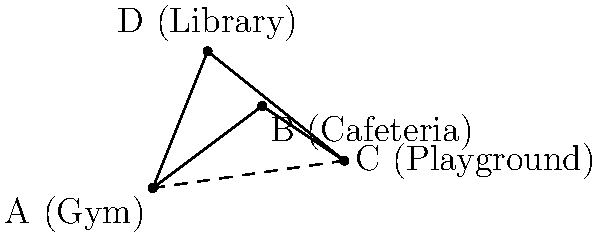As the school wellness coordinator, you're planning an efficient walking route between school facilities to encourage physical activity. Given the layout of the school facilities represented by vectors, where A is the gym, B is the cafeteria, C is the playground, and D is the library, what is the magnitude of the vector from the gym (A) to the playground (C)? To find the magnitude of the vector from the gym (A) to the playground (C), we need to follow these steps:

1. Identify the coordinates of points A and C:
   A (Gym): (0, 0)
   C (Playground): (7, 1)

2. Calculate the vector $\vec{AC}$ by subtracting the coordinates of A from C:
   $\vec{AC} = (7-0, 1-0) = (7, 1)$

3. Use the magnitude formula for a 2D vector:
   For a vector $\vec{v} = (x, y)$, the magnitude is given by $|\vec{v}| = \sqrt{x^2 + y^2}$

4. Apply the formula to $\vec{AC}$:
   $|\vec{AC}| = \sqrt{7^2 + 1^2}$

5. Simplify:
   $|\vec{AC}| = \sqrt{49 + 1} = \sqrt{50}$

6. Simplify further:
   $|\vec{AC}| = 5\sqrt{2}$

The magnitude of the vector from the gym (A) to the playground (C) is $5\sqrt{2}$ units.
Answer: $5\sqrt{2}$ units 